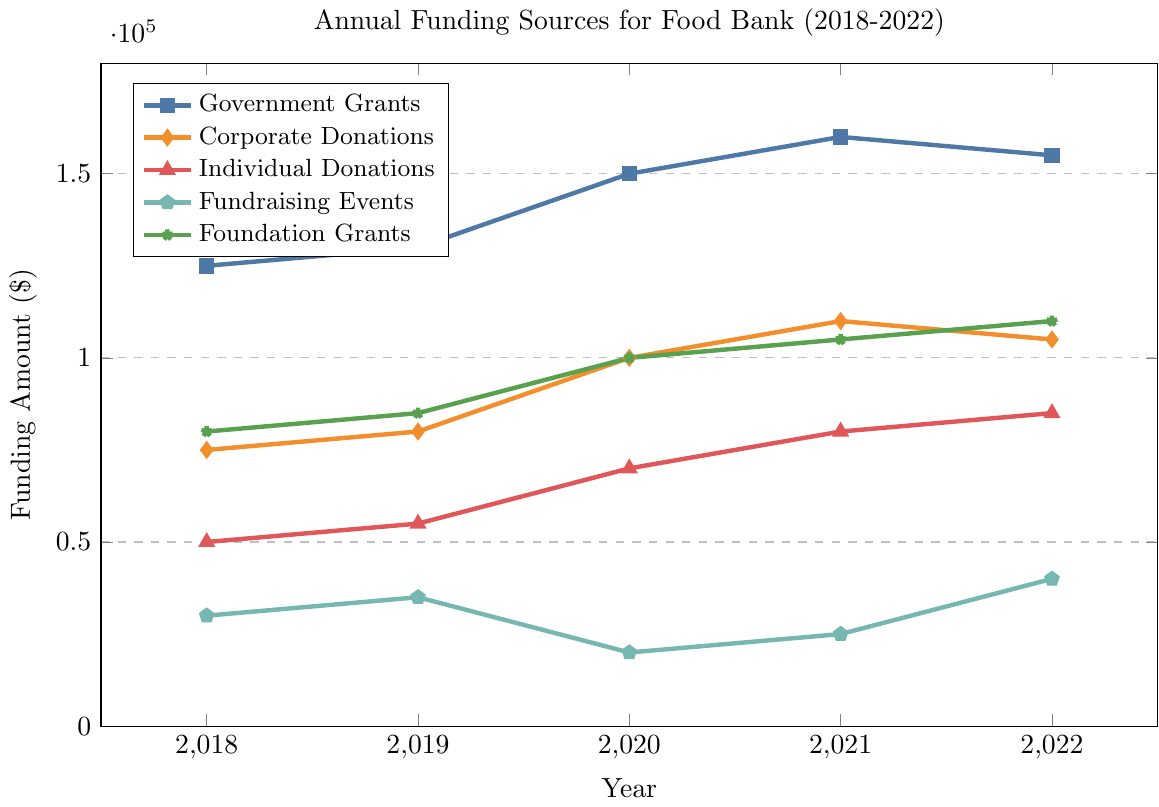What is the total amount of funding from Government Grants and Corporate Donations in 2021? First, identify the funding amount from Government Grants in 2021, which is $160,000. Then, find the funding amount from Corporate Donations in 2021, which is $110,000. Sum these amounts: $160,000 + $110,000 = $270,000
Answer: $270,000 Did Individual Donations increase every year from 2018 to 2022? Examine the values for Individual Donations from 2018 to 2022: $50,000 in 2018, $55,000 in 2019, $70,000 in 2020, $80,000 in 2021, and $85,000 in 2022. Each year shows an increase from the previous year.
Answer: Yes Which funding source had the highest increase in absolute value from 2018 to 2022? Calculate the increase for each source from 2018 to 2022. For Government Grants: $155,000 - $125,000 = $30,000. For Corporate Donations: $105,000 - $75,000 = $30,000. For Individual Donations: $85,000 - $50,000 = $35,000. For Fundraising Events: $40,000 - $30,000 = $10,000. For Foundation Grants: $110,000 - $80,000 = $30,000. The highest increase is $35,000 by Individual Donations.
Answer: Individual Donations What is the percentage increase in Foundation Grants from 2018 to 2022? Calculate the difference in Foundation Grants from 2018 to 2022, which is $110,000 - $80,000 = $30,000. Then, divide the increase by the 2018 value and multiply by 100 to get the percentage: ($30,000 / $80,000) * 100 = 37.5%
Answer: 37.5% In which year did Fundraising Events have the lowest funding amount, and what was it? Look at the values for Fundraising Events from 2018 to 2022: $30,000 in 2018, $35,000 in 2019, $20,000 in 2020, $25,000 in 2021, and $40,000 in 2022. The lowest amount was in 2020, with $20,000.
Answer: 2020, $20,000 How does the funding from Government Grants in 2020 compare to Individual Donations in the same year? The funding amount from Government Grants in 2020 is $150,000, and the funding amount from Individual Donations in 2020 is $70,000. Comparing the two values, Government Grants are greater than Individual Donations.
Answer: Government Grants are greater What is the average funding amount received from Corporate Donations over the 5 years? Add the values for Corporate Donations from 2018 to 2022: $75,000 + $80,000 + $100,000 + $110,000 + $105,000 = $470,000. Then, divide by the number of years (5): $470,000 / 5 = $94,000.
Answer: $94,000 